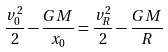Convert formula to latex. <formula><loc_0><loc_0><loc_500><loc_500>\frac { v _ { 0 } ^ { 2 } } { 2 } - \frac { G M } { x _ { 0 } } = \frac { v _ { R } ^ { 2 } } { 2 } - \frac { G M } { R }</formula> 